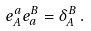<formula> <loc_0><loc_0><loc_500><loc_500>e _ { A } ^ { a } e _ { a } ^ { B } = \delta ^ { B } _ { A } \, .</formula> 